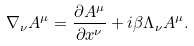Convert formula to latex. <formula><loc_0><loc_0><loc_500><loc_500>\nabla _ { \nu } A ^ { \mu } = \frac { \partial A ^ { \mu } } { \partial x ^ { \nu } } + i \beta \Lambda _ { \nu } A ^ { \mu } .</formula> 